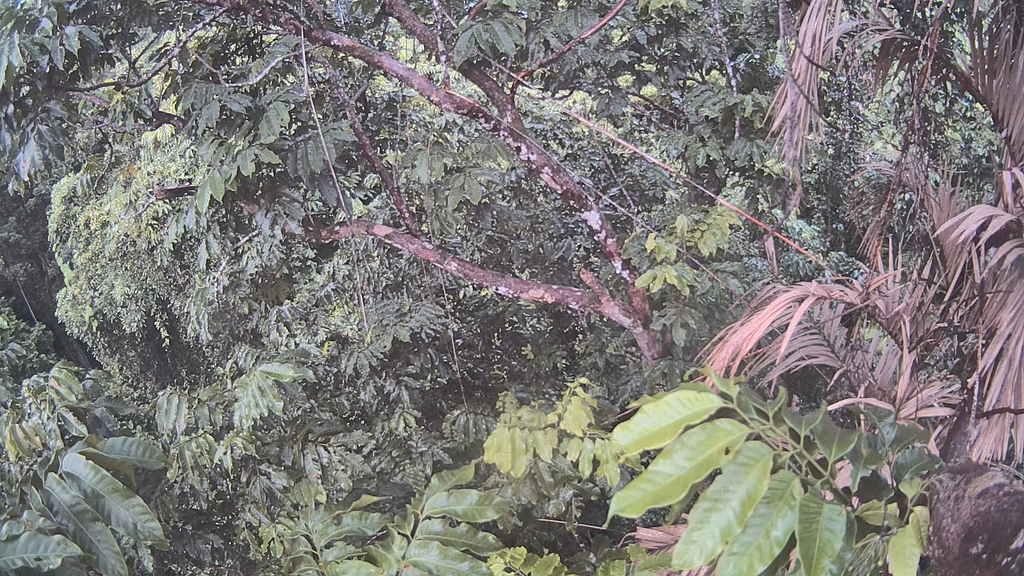Could you give a brief overview of what you see in this image? In this picture I can see few trees in the middle. 